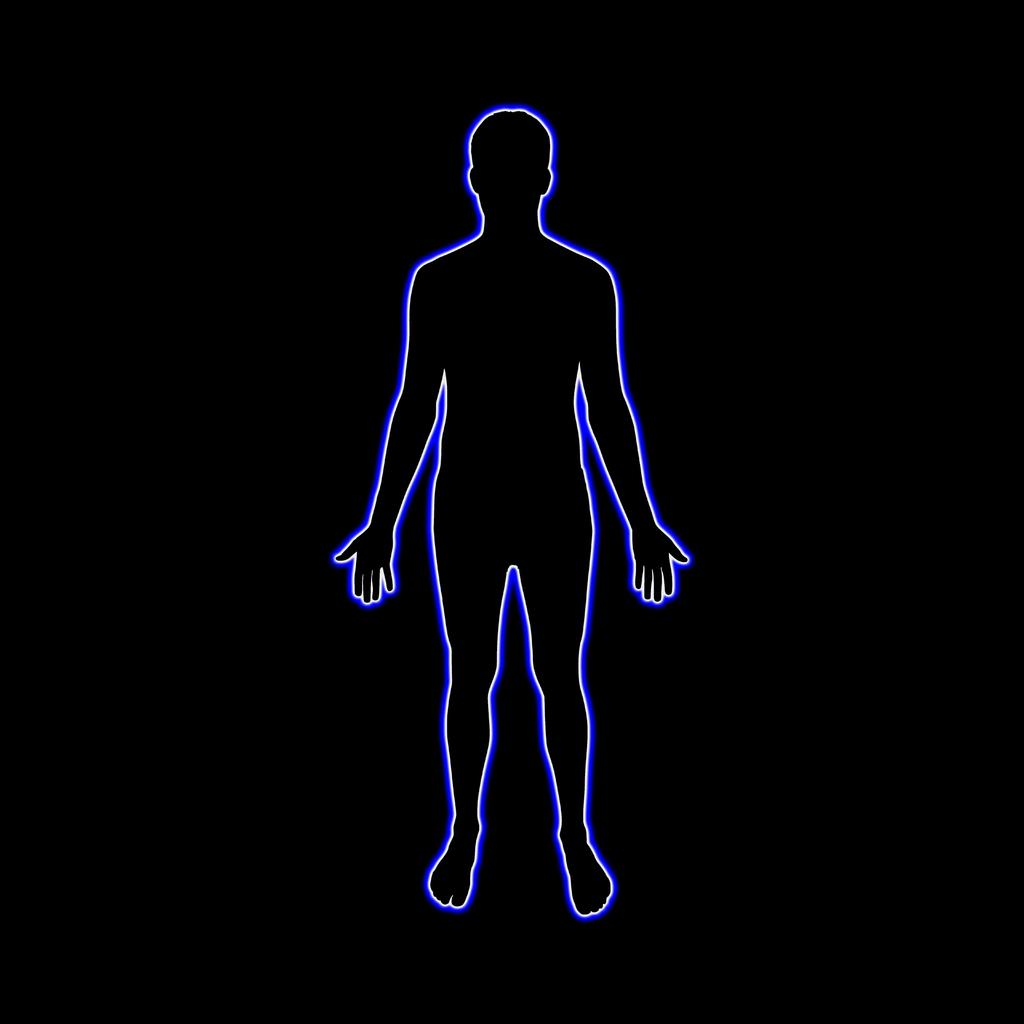What is the main subject of the image? There is a shape of a human body in the image. What color is the shape? The shape is colored blue. What color is the background of the image? The background of the image is black. Where is the shelf located in the image? There is no shelf present in the image. What type of hose can be seen connected to the shape in the image? There is no hose present in the image; it only features a blue shape on a black background. 